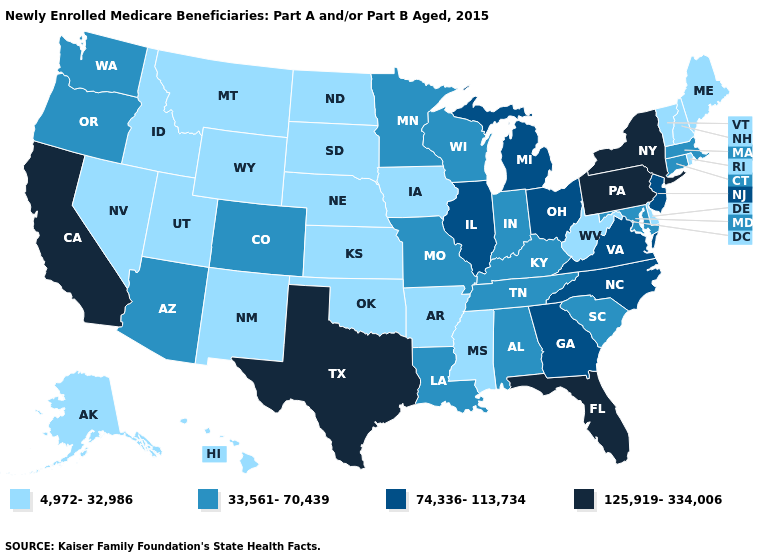What is the value of Georgia?
Keep it brief. 74,336-113,734. Does California have a higher value than New York?
Write a very short answer. No. What is the value of Ohio?
Keep it brief. 74,336-113,734. What is the lowest value in the West?
Keep it brief. 4,972-32,986. What is the value of Utah?
Short answer required. 4,972-32,986. Name the states that have a value in the range 4,972-32,986?
Short answer required. Alaska, Arkansas, Delaware, Hawaii, Idaho, Iowa, Kansas, Maine, Mississippi, Montana, Nebraska, Nevada, New Hampshire, New Mexico, North Dakota, Oklahoma, Rhode Island, South Dakota, Utah, Vermont, West Virginia, Wyoming. Which states have the highest value in the USA?
Concise answer only. California, Florida, New York, Pennsylvania, Texas. Does Pennsylvania have the highest value in the USA?
Answer briefly. Yes. What is the highest value in the USA?
Answer briefly. 125,919-334,006. Among the states that border Arizona , does California have the highest value?
Be succinct. Yes. Among the states that border Vermont , does New York have the lowest value?
Concise answer only. No. What is the value of Oregon?
Keep it brief. 33,561-70,439. What is the lowest value in the West?
Concise answer only. 4,972-32,986. What is the value of Oklahoma?
Be succinct. 4,972-32,986. Among the states that border West Virginia , which have the lowest value?
Short answer required. Kentucky, Maryland. 